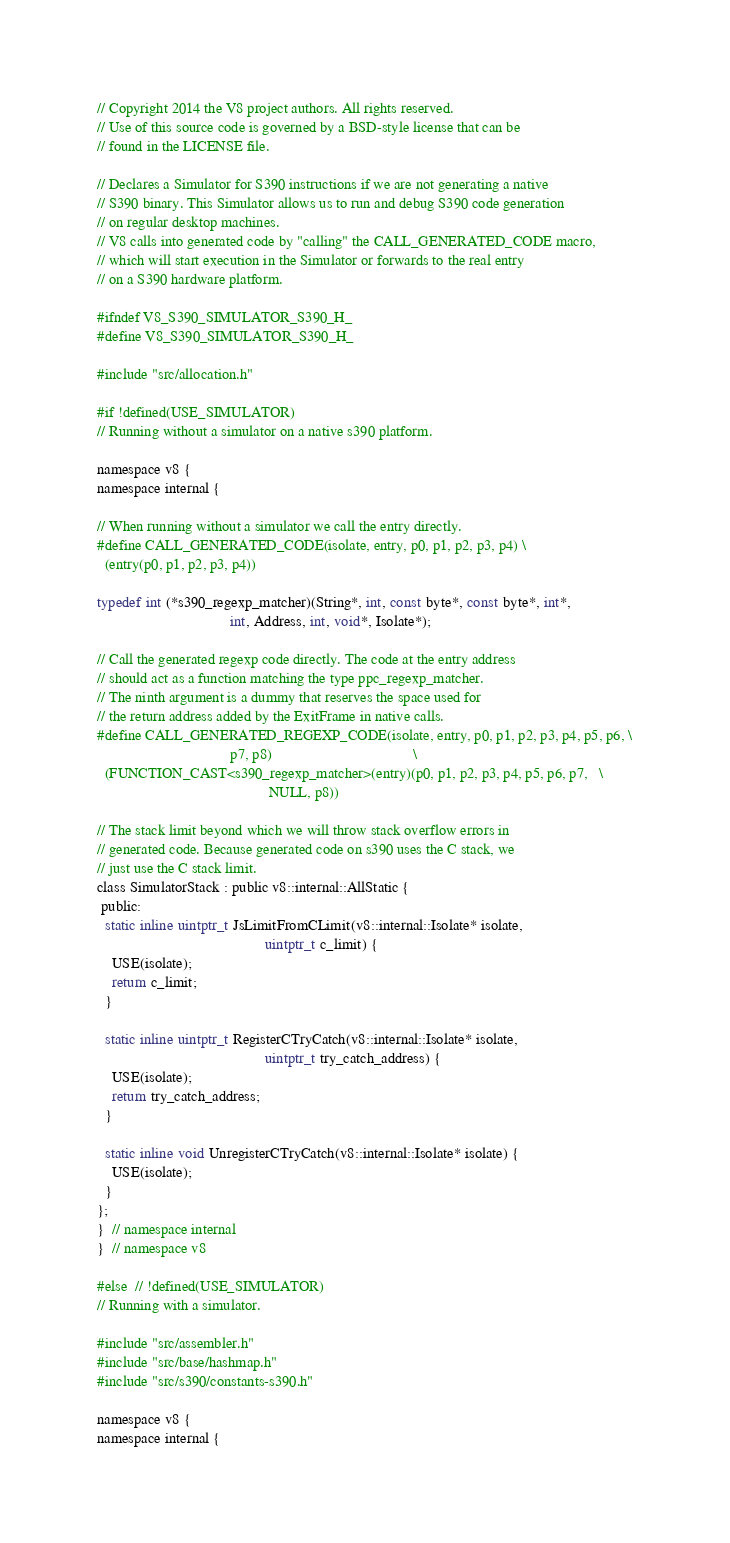<code> <loc_0><loc_0><loc_500><loc_500><_C_>// Copyright 2014 the V8 project authors. All rights reserved.
// Use of this source code is governed by a BSD-style license that can be
// found in the LICENSE file.

// Declares a Simulator for S390 instructions if we are not generating a native
// S390 binary. This Simulator allows us to run and debug S390 code generation
// on regular desktop machines.
// V8 calls into generated code by "calling" the CALL_GENERATED_CODE macro,
// which will start execution in the Simulator or forwards to the real entry
// on a S390 hardware platform.

#ifndef V8_S390_SIMULATOR_S390_H_
#define V8_S390_SIMULATOR_S390_H_

#include "src/allocation.h"

#if !defined(USE_SIMULATOR)
// Running without a simulator on a native s390 platform.

namespace v8 {
namespace internal {

// When running without a simulator we call the entry directly.
#define CALL_GENERATED_CODE(isolate, entry, p0, p1, p2, p3, p4) \
  (entry(p0, p1, p2, p3, p4))

typedef int (*s390_regexp_matcher)(String*, int, const byte*, const byte*, int*,
                                   int, Address, int, void*, Isolate*);

// Call the generated regexp code directly. The code at the entry address
// should act as a function matching the type ppc_regexp_matcher.
// The ninth argument is a dummy that reserves the space used for
// the return address added by the ExitFrame in native calls.
#define CALL_GENERATED_REGEXP_CODE(isolate, entry, p0, p1, p2, p3, p4, p5, p6, \
                                   p7, p8)                                     \
  (FUNCTION_CAST<s390_regexp_matcher>(entry)(p0, p1, p2, p3, p4, p5, p6, p7,   \
                                             NULL, p8))

// The stack limit beyond which we will throw stack overflow errors in
// generated code. Because generated code on s390 uses the C stack, we
// just use the C stack limit.
class SimulatorStack : public v8::internal::AllStatic {
 public:
  static inline uintptr_t JsLimitFromCLimit(v8::internal::Isolate* isolate,
                                            uintptr_t c_limit) {
    USE(isolate);
    return c_limit;
  }

  static inline uintptr_t RegisterCTryCatch(v8::internal::Isolate* isolate,
                                            uintptr_t try_catch_address) {
    USE(isolate);
    return try_catch_address;
  }

  static inline void UnregisterCTryCatch(v8::internal::Isolate* isolate) {
    USE(isolate);
  }
};
}  // namespace internal
}  // namespace v8

#else  // !defined(USE_SIMULATOR)
// Running with a simulator.

#include "src/assembler.h"
#include "src/base/hashmap.h"
#include "src/s390/constants-s390.h"

namespace v8 {
namespace internal {
</code> 